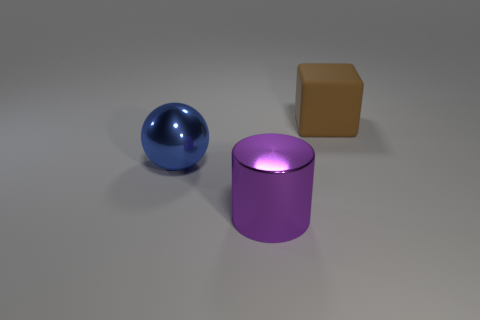Are there more large brown rubber cubes in front of the purple cylinder than brown objects that are to the right of the large cube?
Your answer should be very brief. No. What number of other objects are the same size as the brown object?
Keep it short and to the point. 2. Do the brown rubber thing and the big object that is in front of the metal sphere have the same shape?
Your response must be concise. No. How many matte objects are either yellow cylinders or big blue spheres?
Your answer should be very brief. 0. Are there any big metallic things that have the same color as the matte cube?
Offer a very short reply. No. Are any small blue metal balls visible?
Give a very brief answer. No. Do the brown rubber thing and the purple object have the same shape?
Provide a short and direct response. No. What number of tiny things are either shiny objects or brown matte spheres?
Make the answer very short. 0. What color is the block?
Keep it short and to the point. Brown. The large object to the right of the large metallic object in front of the big blue metallic ball is what shape?
Ensure brevity in your answer.  Cube. 